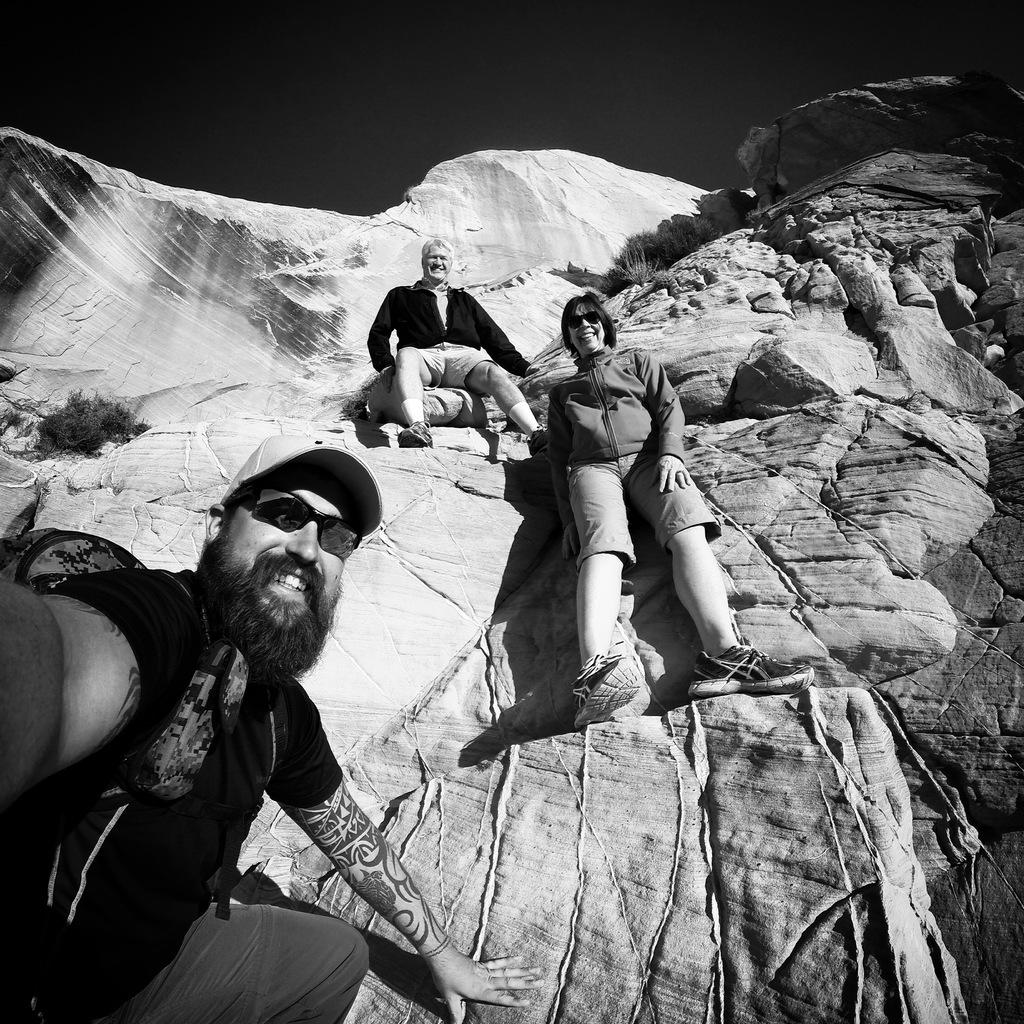How many people are in the image? There are three people in the image. What are the people doing in the image? The people are sitting on rocks and smiling. What can be seen in the background of the image? There are rocky mountains in the background of the image. What is visible at the top of the image? The sky is visible at the top of the image. What type of music can be heard playing in the background of the image? There is no music present in the image; it is a still photograph of three people sitting on rocks. 